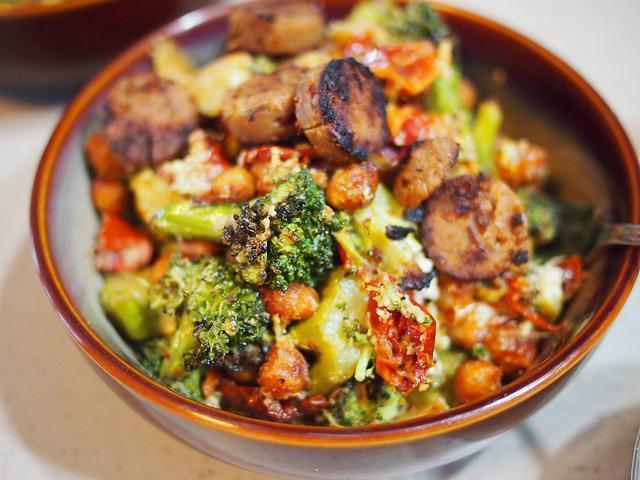How many broccolis are in the photo?
Give a very brief answer. 5. How many people are wearing a jacket in the picture?
Give a very brief answer. 0. 